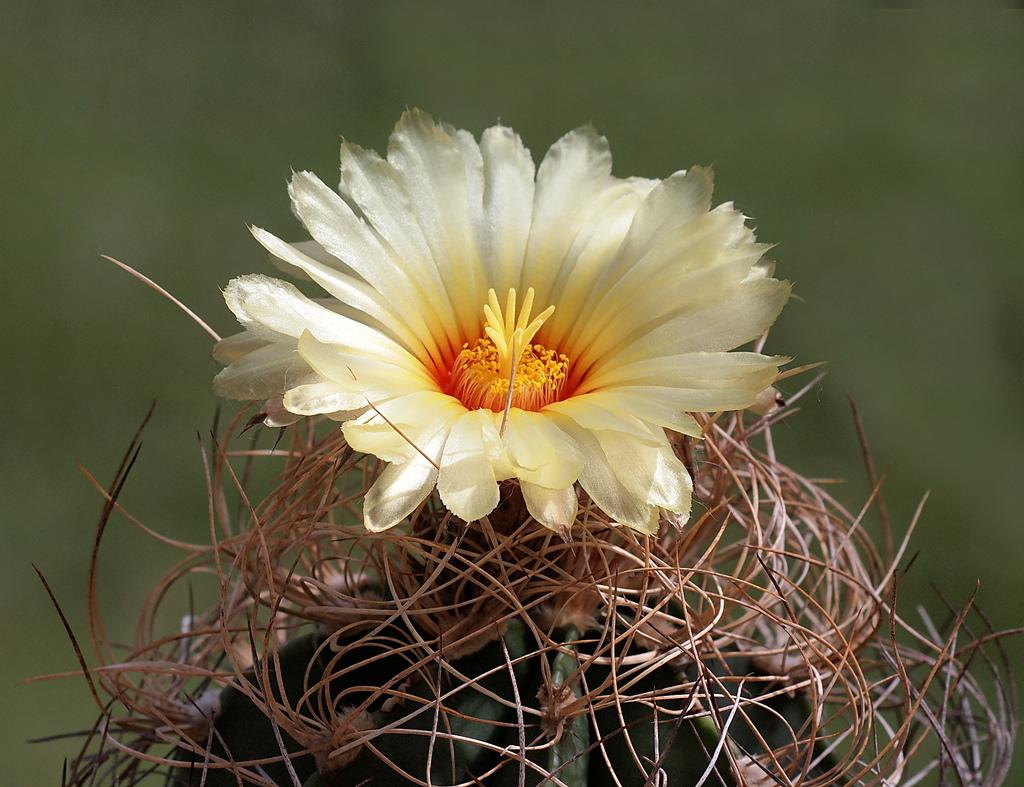What type of plant is visible in the image? There is a flower in the image, which is a type of plant. What colors can be seen on the flower? The flower has cream, yellow, and orange colors. What other plant is present in the image? There is a plant in the image. What colors can be seen on the plant? The plant has green and brown colors. How would you describe the background of the image? The background of the image is blurry and green in color. What type of island can be seen in the background of the image? There is no island present in the image; the background is blurry and green in color. What type of secretary is visible in the image? There is no secretary present in the image; the main subjects are the flower and the plant. 